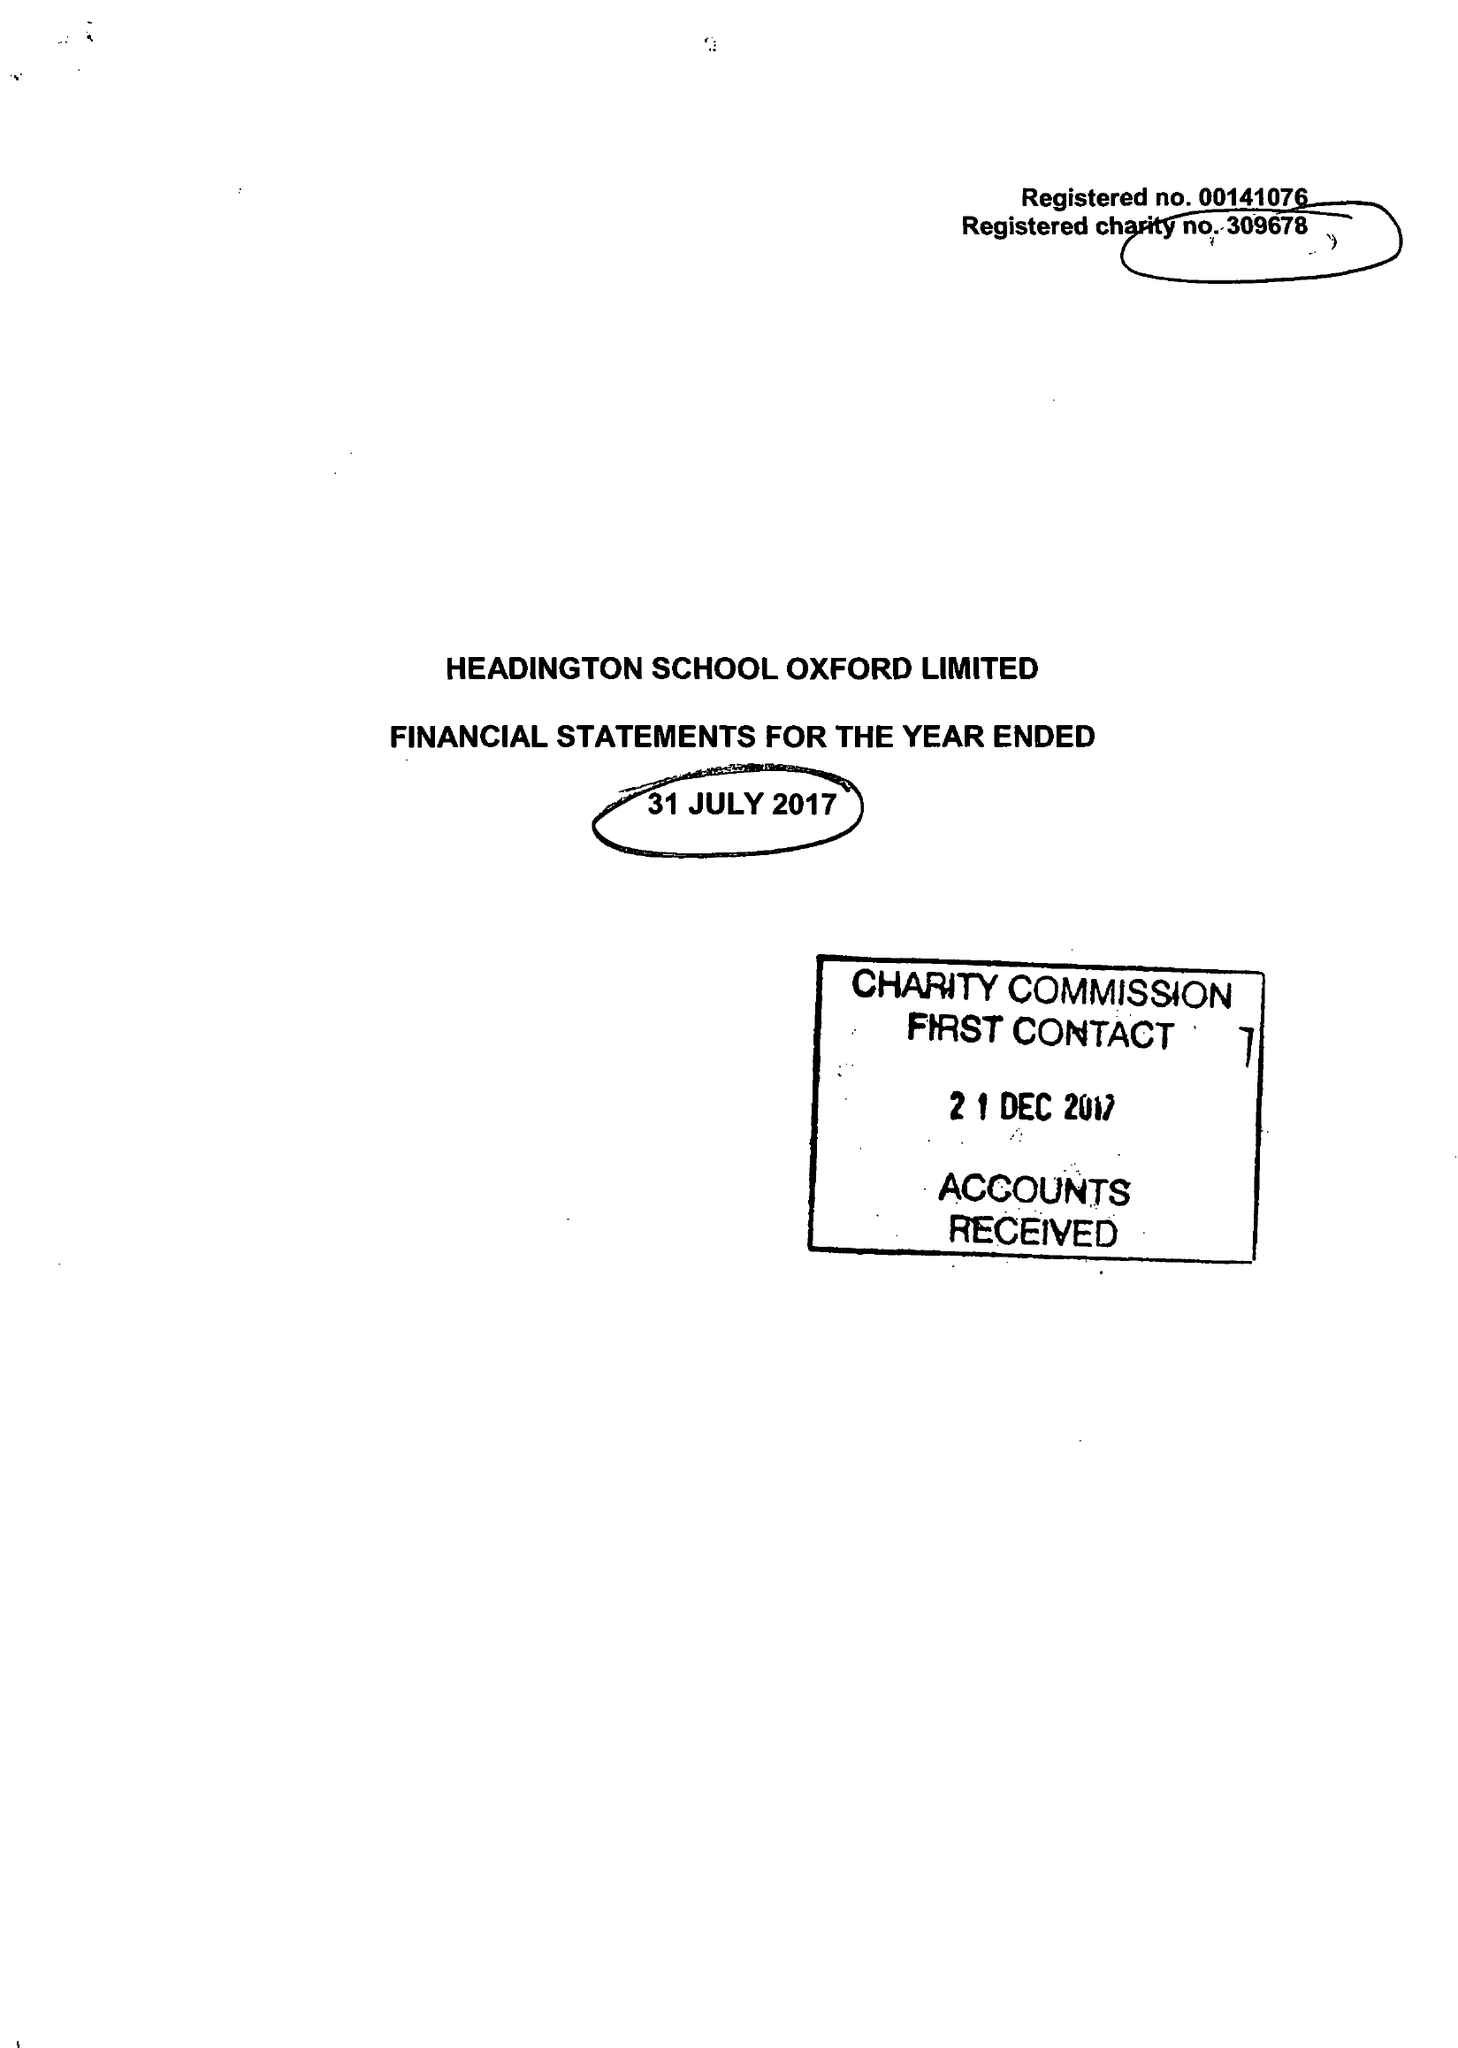What is the value for the address__street_line?
Answer the question using a single word or phrase. None 